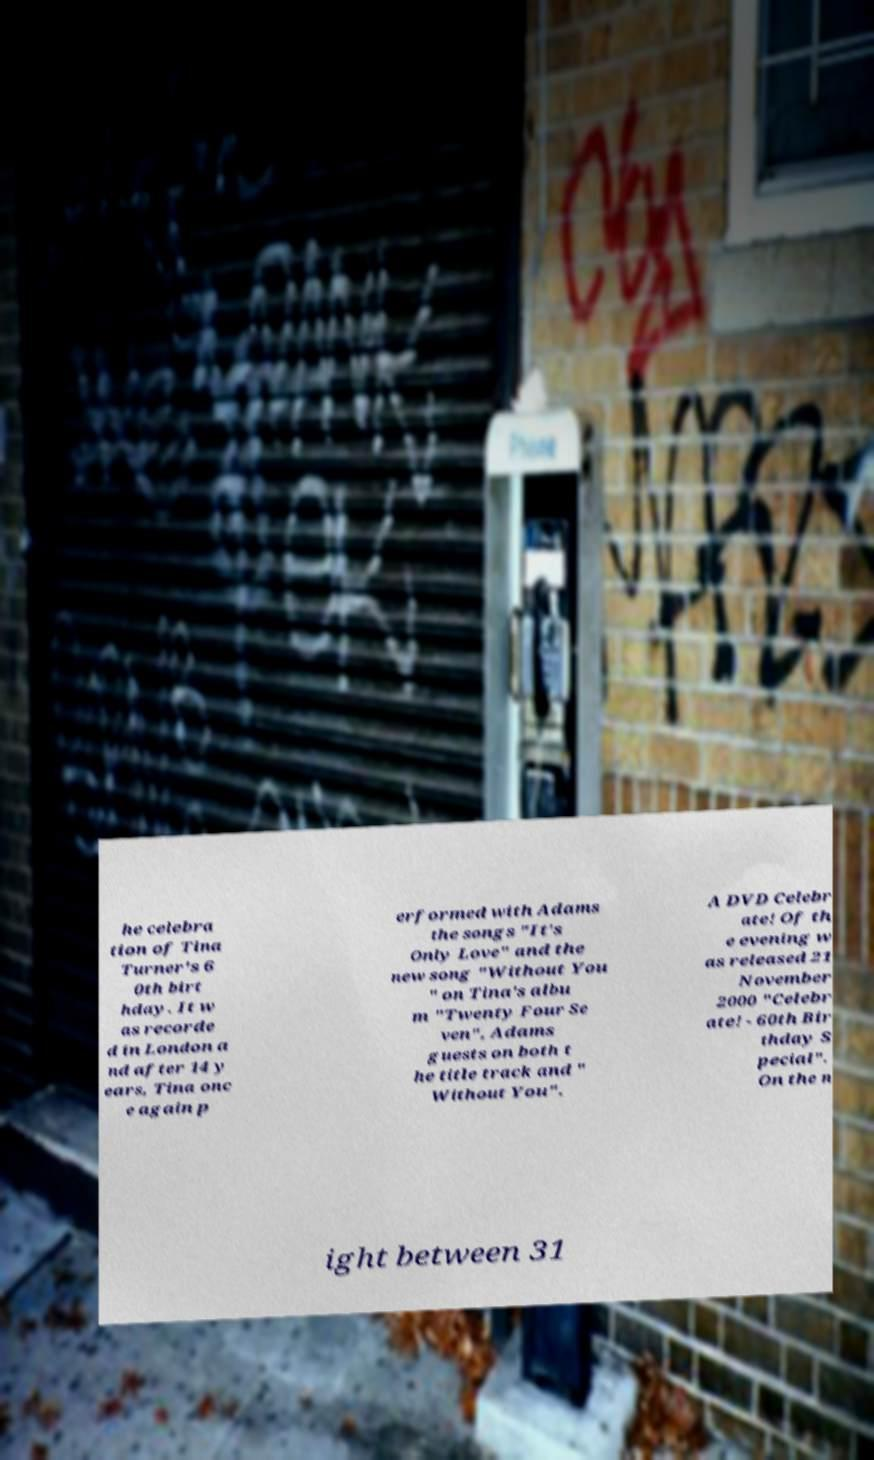Please identify and transcribe the text found in this image. he celebra tion of Tina Turner's 6 0th birt hday. It w as recorde d in London a nd after 14 y ears, Tina onc e again p erformed with Adams the songs "It's Only Love" and the new song "Without You " on Tina's albu m "Twenty Four Se ven", Adams guests on both t he title track and " Without You". A DVD Celebr ate! Of th e evening w as released 21 November 2000 "Celebr ate! - 60th Bir thday S pecial". On the n ight between 31 